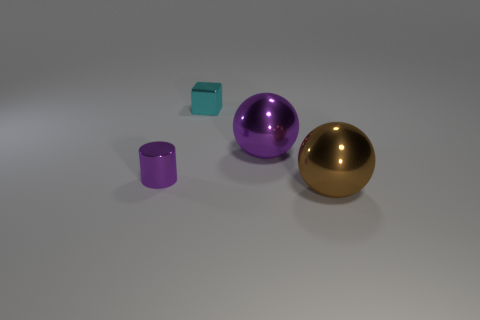There is a large thing that is the same color as the tiny cylinder; what shape is it?
Your answer should be very brief. Sphere. What material is the purple thing to the right of the object that is behind the big purple sphere?
Provide a short and direct response. Metal. Is there a thing that has the same color as the tiny cylinder?
Provide a succinct answer. Yes. What is the size of the other ball that is the same material as the big purple ball?
Your response must be concise. Large. Are there any other things that are the same color as the tiny cube?
Keep it short and to the point. No. There is a tiny thing that is on the left side of the cube; what color is it?
Your answer should be very brief. Purple. Are there any purple shiny balls in front of the metallic sphere that is left of the big metallic ball in front of the tiny cylinder?
Your answer should be very brief. No. Is the number of small purple cylinders that are on the left side of the metal cylinder greater than the number of small gray cylinders?
Your response must be concise. No. Do the large object that is behind the purple metal cylinder and the small purple thing have the same shape?
Offer a very short reply. No. Is there anything else that has the same material as the cyan block?
Ensure brevity in your answer.  Yes. 